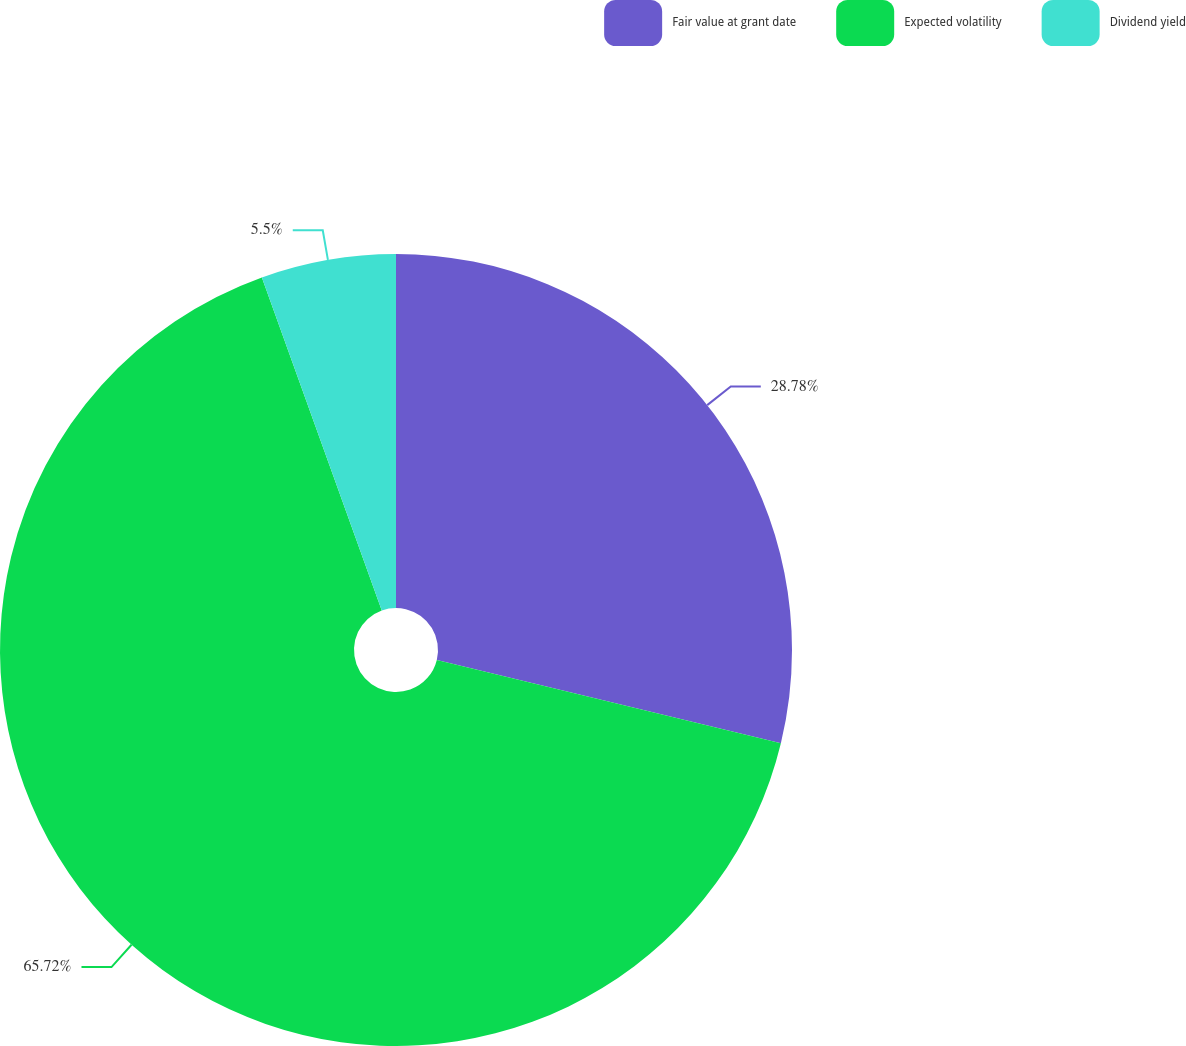Convert chart to OTSL. <chart><loc_0><loc_0><loc_500><loc_500><pie_chart><fcel>Fair value at grant date<fcel>Expected volatility<fcel>Dividend yield<nl><fcel>28.78%<fcel>65.72%<fcel>5.5%<nl></chart> 